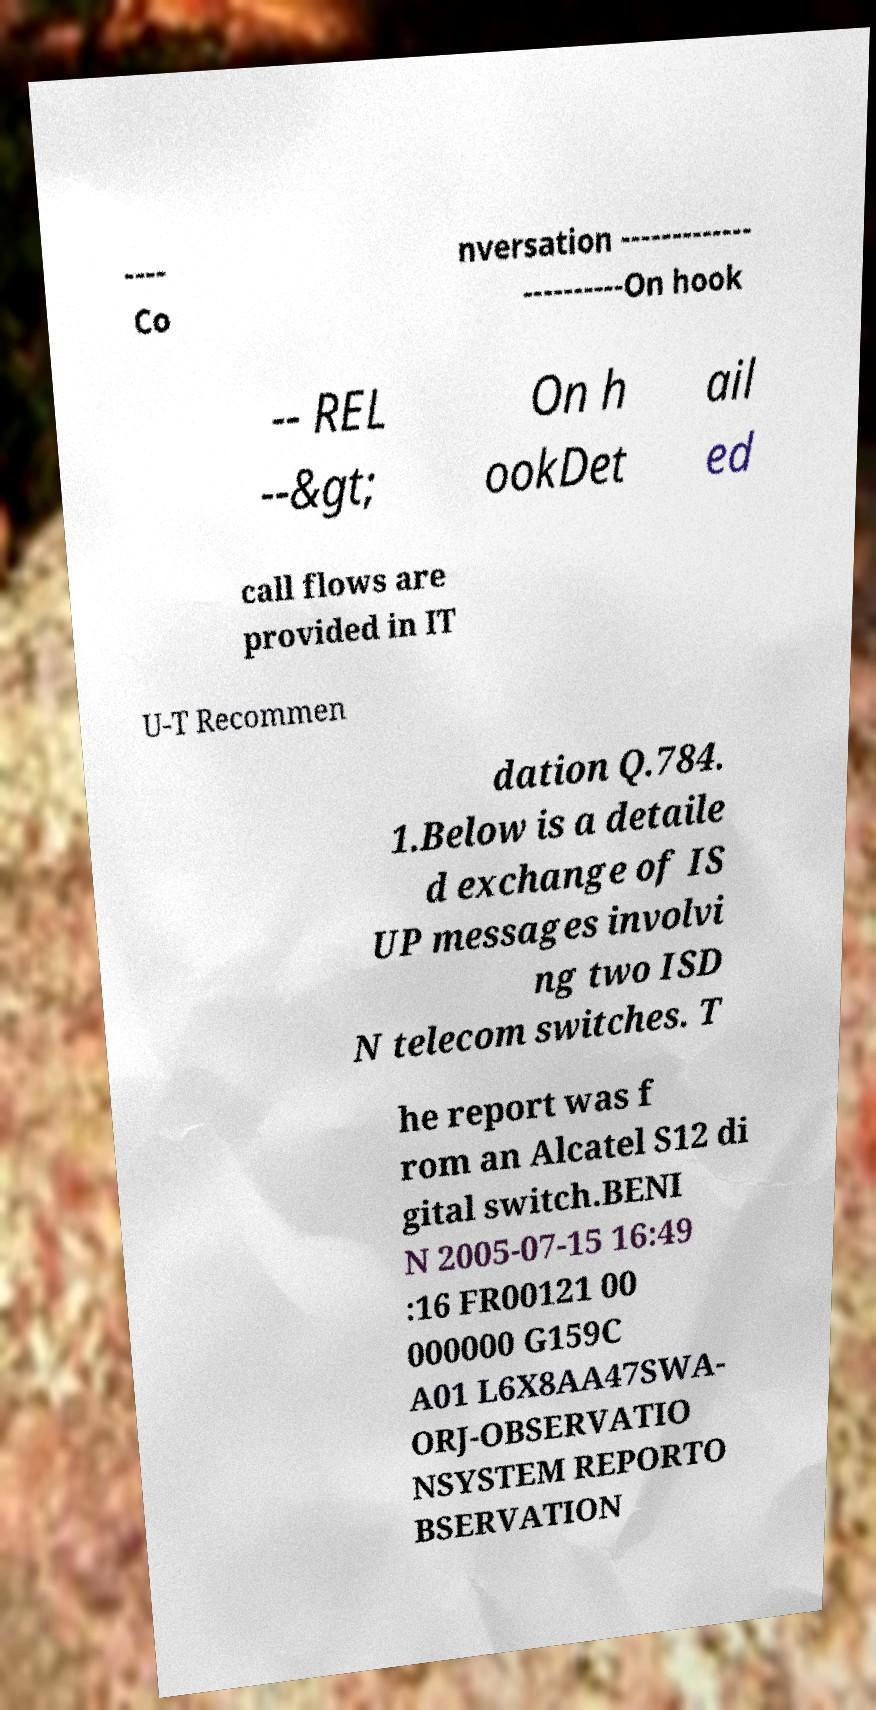There's text embedded in this image that I need extracted. Can you transcribe it verbatim? ---- Co nversation ------------- ----------On hook -- REL --&gt; On h ookDet ail ed call flows are provided in IT U-T Recommen dation Q.784. 1.Below is a detaile d exchange of IS UP messages involvi ng two ISD N telecom switches. T he report was f rom an Alcatel S12 di gital switch.BENI N 2005-07-15 16:49 :16 FR00121 00 000000 G159C A01 L6X8AA47SWA- ORJ-OBSERVATIO NSYSTEM REPORTO BSERVATION 